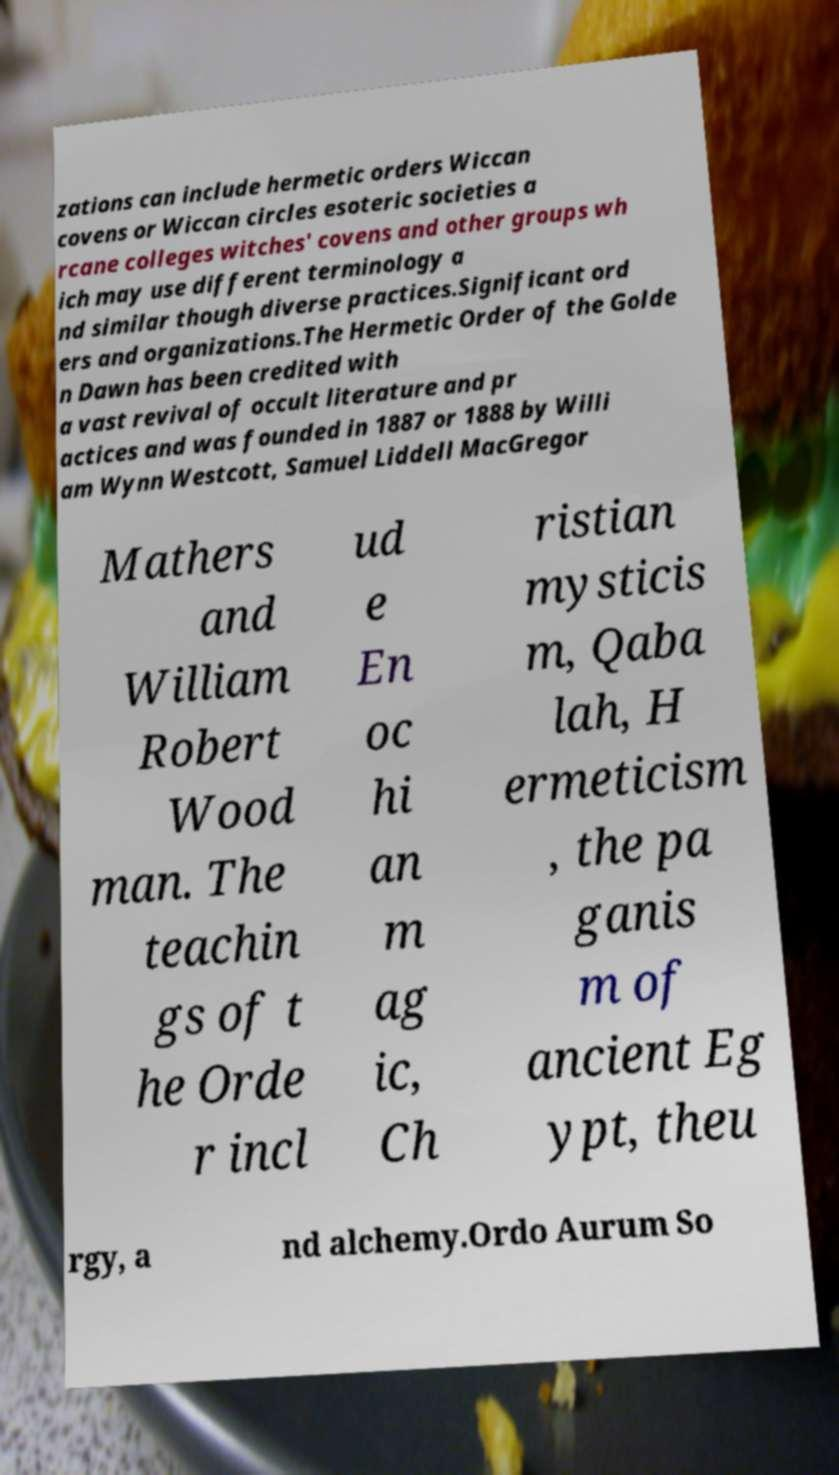Could you extract and type out the text from this image? zations can include hermetic orders Wiccan covens or Wiccan circles esoteric societies a rcane colleges witches' covens and other groups wh ich may use different terminology a nd similar though diverse practices.Significant ord ers and organizations.The Hermetic Order of the Golde n Dawn has been credited with a vast revival of occult literature and pr actices and was founded in 1887 or 1888 by Willi am Wynn Westcott, Samuel Liddell MacGregor Mathers and William Robert Wood man. The teachin gs of t he Orde r incl ud e En oc hi an m ag ic, Ch ristian mysticis m, Qaba lah, H ermeticism , the pa ganis m of ancient Eg ypt, theu rgy, a nd alchemy.Ordo Aurum So 